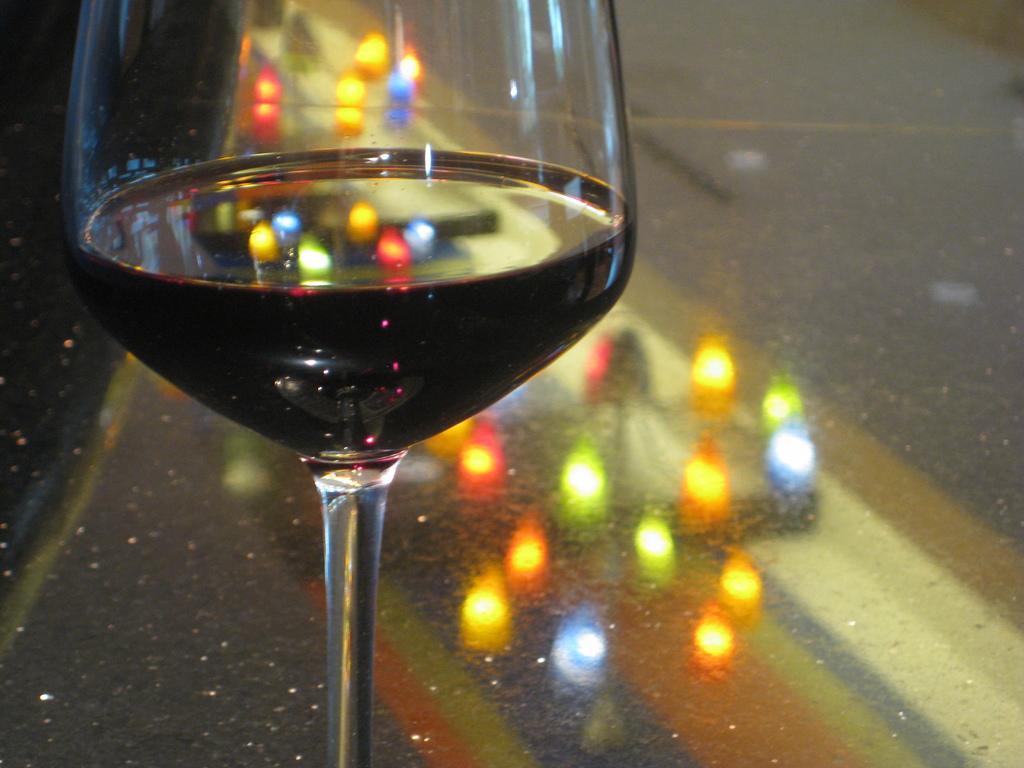Could you give a brief overview of what you see in this image? In this image, we can see a glass and we can see the reflection of the lights on the glass. 